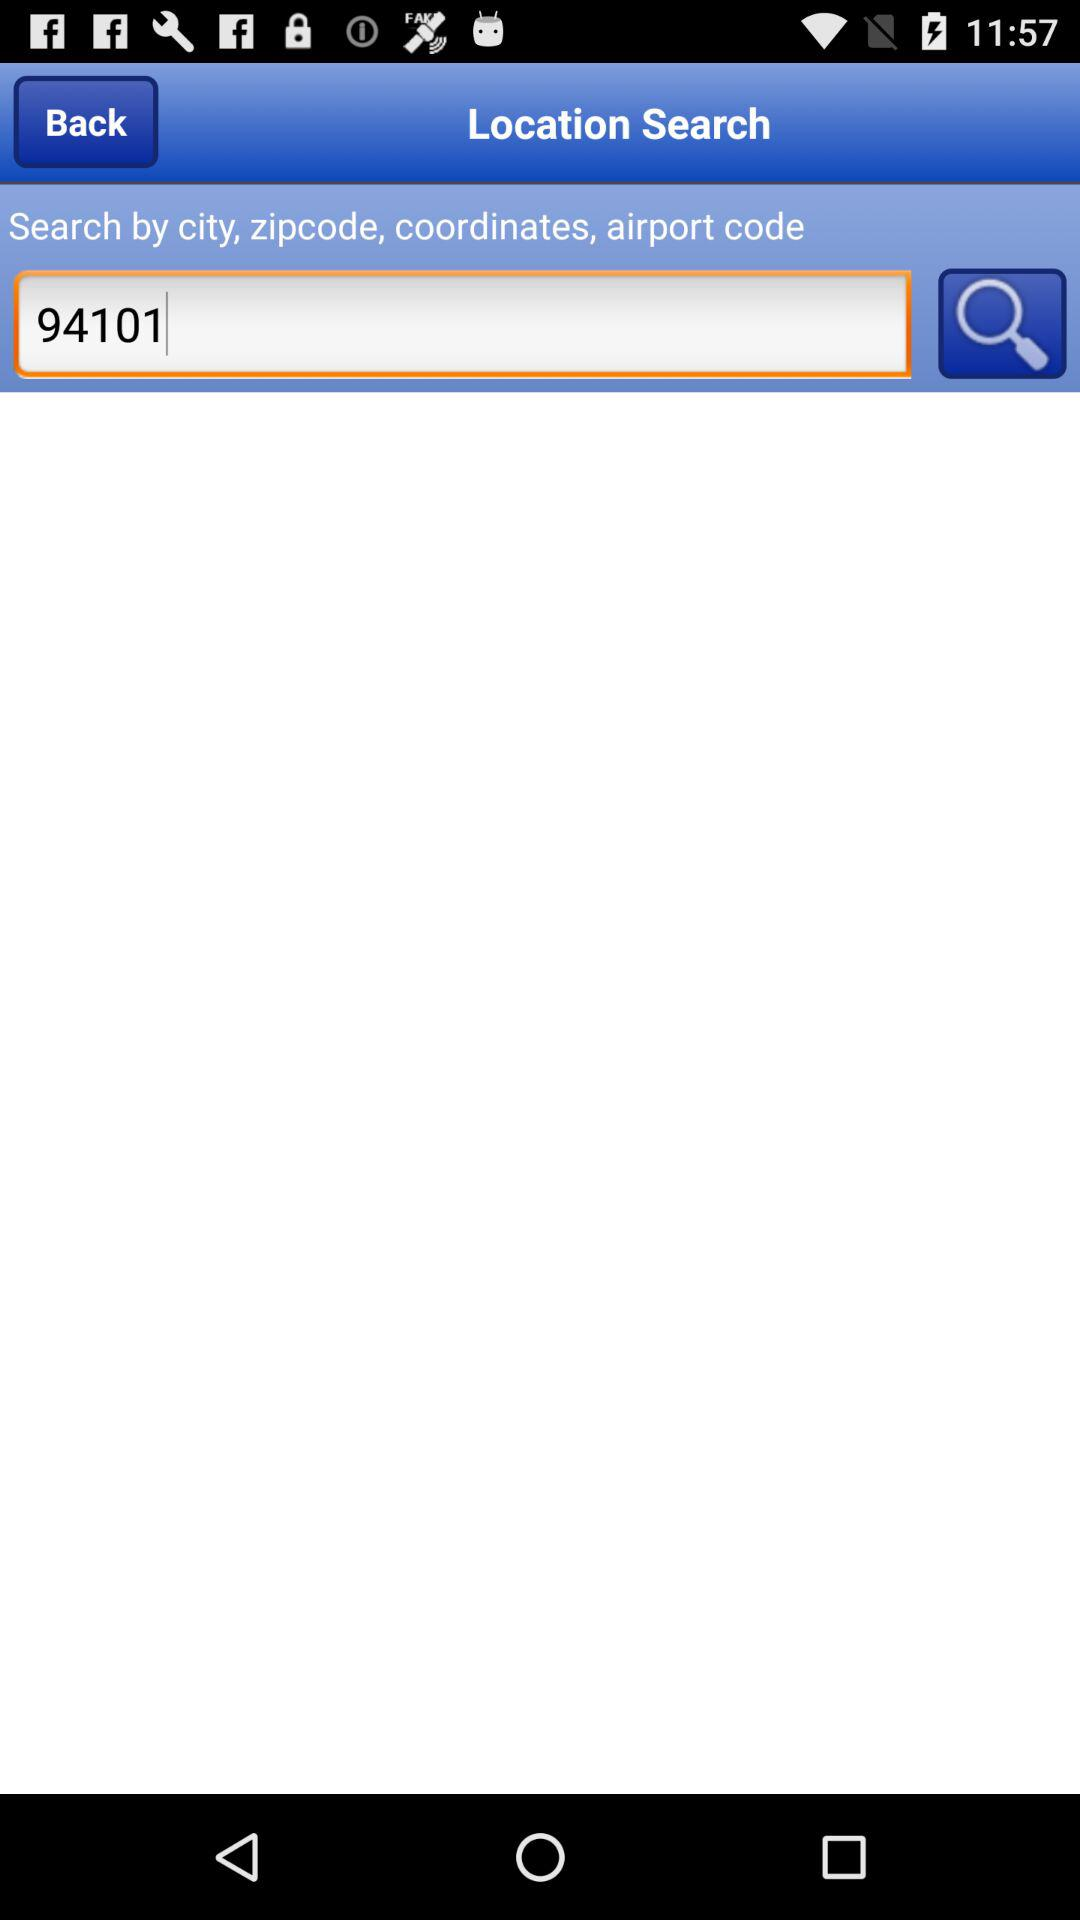What is the zip code? The zip code is 94101. 